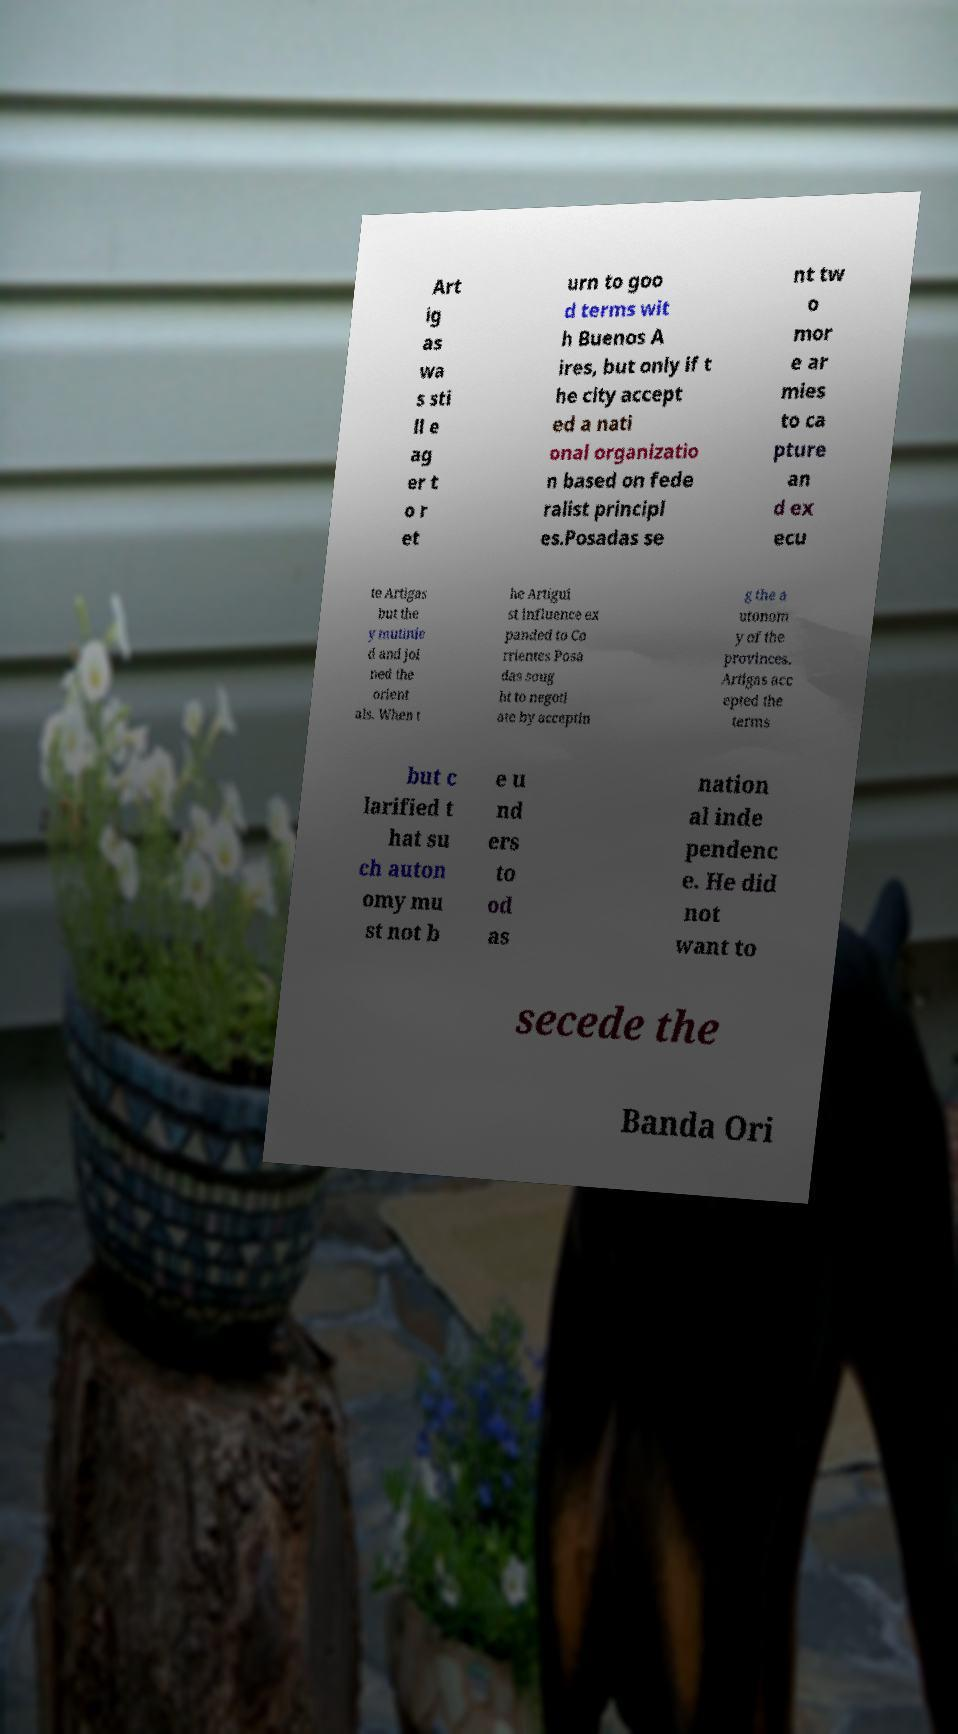Could you extract and type out the text from this image? Art ig as wa s sti ll e ag er t o r et urn to goo d terms wit h Buenos A ires, but only if t he city accept ed a nati onal organizatio n based on fede ralist principl es.Posadas se nt tw o mor e ar mies to ca pture an d ex ecu te Artigas but the y mutinie d and joi ned the orient als. When t he Artigui st influence ex panded to Co rrientes Posa das soug ht to negoti ate by acceptin g the a utonom y of the provinces. Artigas acc epted the terms but c larified t hat su ch auton omy mu st not b e u nd ers to od as nation al inde pendenc e. He did not want to secede the Banda Ori 